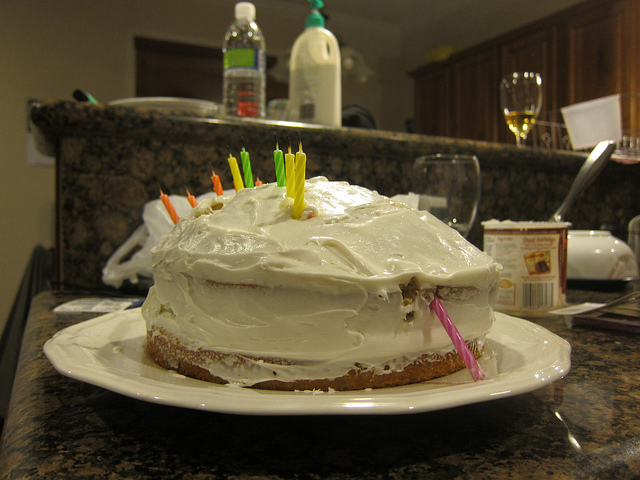What ingredients might be used for the frosting on this cake? The frosting on the cake looks creamy and smooth, which suggests it might be a buttercream frosting. Typically, such frosting is made from powdered sugar, butter, vanilla extract, and milk or cream. 